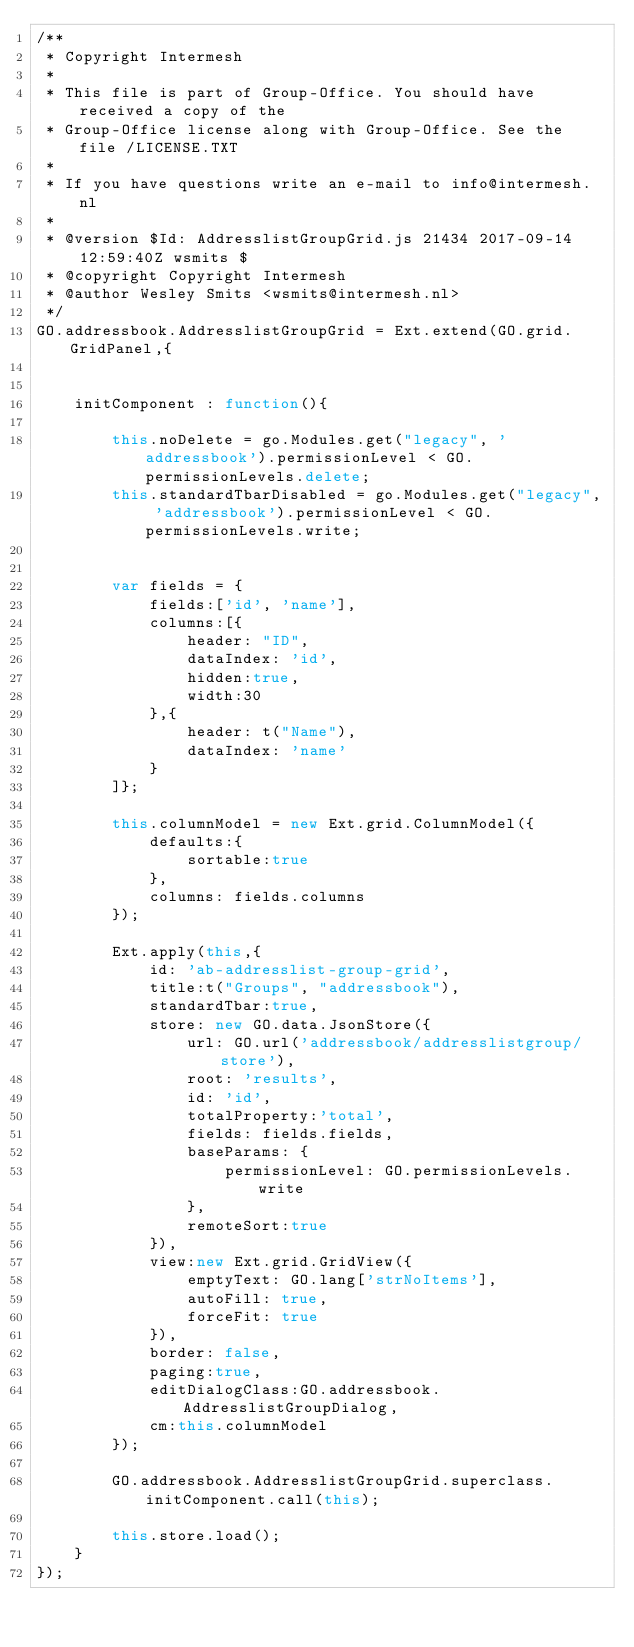<code> <loc_0><loc_0><loc_500><loc_500><_JavaScript_>/** 
 * Copyright Intermesh
 * 
 * This file is part of Group-Office. You should have received a copy of the
 * Group-Office license along with Group-Office. See the file /LICENSE.TXT
 * 
 * If you have questions write an e-mail to info@intermesh.nl
 * 
 * @version $Id: AddresslistGroupGrid.js 21434 2017-09-14 12:59:40Z wsmits $
 * @copyright Copyright Intermesh
 * @author Wesley Smits <wsmits@intermesh.nl>
 */
GO.addressbook.AddresslistGroupGrid = Ext.extend(GO.grid.GridPanel,{
	
	
	initComponent : function(){
		
		this.noDelete = go.Modules.get("legacy", 'addressbook').permissionLevel < GO.permissionLevels.delete;
		this.standardTbarDisabled = go.Modules.get("legacy", 'addressbook').permissionLevel < GO.permissionLevels.write;
	

		var fields = {
			fields:['id', 'name'],
			columns:[{
				header: "ID",
				dataIndex: 'id',
				hidden:true,				
				width:30
			},{
				header: t("Name"),
				dataIndex: 'name'
			}
		]};

		this.columnModel = new Ext.grid.ColumnModel({
			defaults:{
				sortable:true
			},
			columns: fields.columns
		});
				
		Ext.apply(this,{
			id: 'ab-addresslist-group-grid',
			title:t("Groups", "addressbook"),
			standardTbar:true,
			store: new GO.data.JsonStore({
				url: GO.url('addressbook/addresslistgroup/store'),
				root: 'results',
				id: 'id',
				totalProperty:'total',
				fields: fields.fields,
				baseParams: {
					permissionLevel: GO.permissionLevels.write
				},
				remoteSort:true
			}),
			view:new Ext.grid.GridView({
				emptyText: GO.lang['strNoItems'],
				autoFill: true,
				forceFit: true
			}),
			border: false,
			paging:true,
			editDialogClass:GO.addressbook.AddresslistGroupDialog,
			cm:this.columnModel
		});
		
		GO.addressbook.AddresslistGroupGrid.superclass.initComponent.call(this);
		
		this.store.load();
	}
});
</code> 